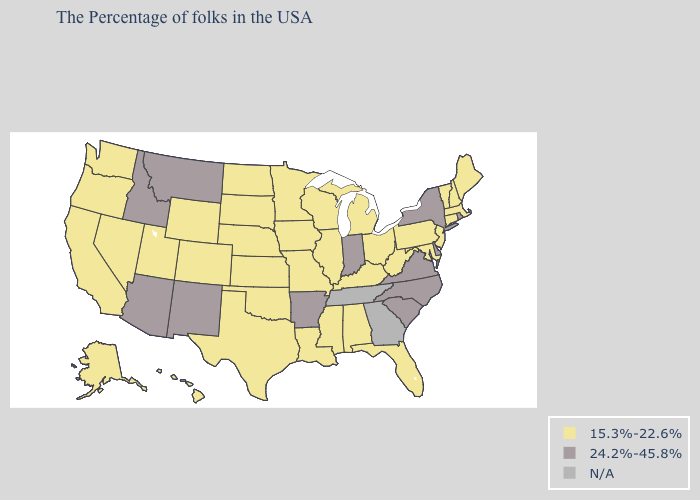What is the lowest value in the West?
Concise answer only. 15.3%-22.6%. What is the value of Oregon?
Short answer required. 15.3%-22.6%. Does the first symbol in the legend represent the smallest category?
Concise answer only. Yes. Which states hav the highest value in the MidWest?
Short answer required. Indiana. Which states have the highest value in the USA?
Short answer required. Rhode Island, New York, Delaware, Virginia, North Carolina, South Carolina, Indiana, Arkansas, New Mexico, Montana, Arizona, Idaho. Among the states that border Wyoming , which have the lowest value?
Quick response, please. Nebraska, South Dakota, Colorado, Utah. What is the value of California?
Quick response, please. 15.3%-22.6%. Which states have the lowest value in the South?
Give a very brief answer. Maryland, West Virginia, Florida, Kentucky, Alabama, Mississippi, Louisiana, Oklahoma, Texas. Name the states that have a value in the range 15.3%-22.6%?
Be succinct. Maine, Massachusetts, New Hampshire, Vermont, Connecticut, New Jersey, Maryland, Pennsylvania, West Virginia, Ohio, Florida, Michigan, Kentucky, Alabama, Wisconsin, Illinois, Mississippi, Louisiana, Missouri, Minnesota, Iowa, Kansas, Nebraska, Oklahoma, Texas, South Dakota, North Dakota, Wyoming, Colorado, Utah, Nevada, California, Washington, Oregon, Alaska, Hawaii. Does Delaware have the lowest value in the USA?
Answer briefly. No. Which states have the lowest value in the South?
Write a very short answer. Maryland, West Virginia, Florida, Kentucky, Alabama, Mississippi, Louisiana, Oklahoma, Texas. Does Missouri have the highest value in the MidWest?
Answer briefly. No. Which states have the lowest value in the USA?
Keep it brief. Maine, Massachusetts, New Hampshire, Vermont, Connecticut, New Jersey, Maryland, Pennsylvania, West Virginia, Ohio, Florida, Michigan, Kentucky, Alabama, Wisconsin, Illinois, Mississippi, Louisiana, Missouri, Minnesota, Iowa, Kansas, Nebraska, Oklahoma, Texas, South Dakota, North Dakota, Wyoming, Colorado, Utah, Nevada, California, Washington, Oregon, Alaska, Hawaii. Among the states that border Oklahoma , which have the lowest value?
Give a very brief answer. Missouri, Kansas, Texas, Colorado. 